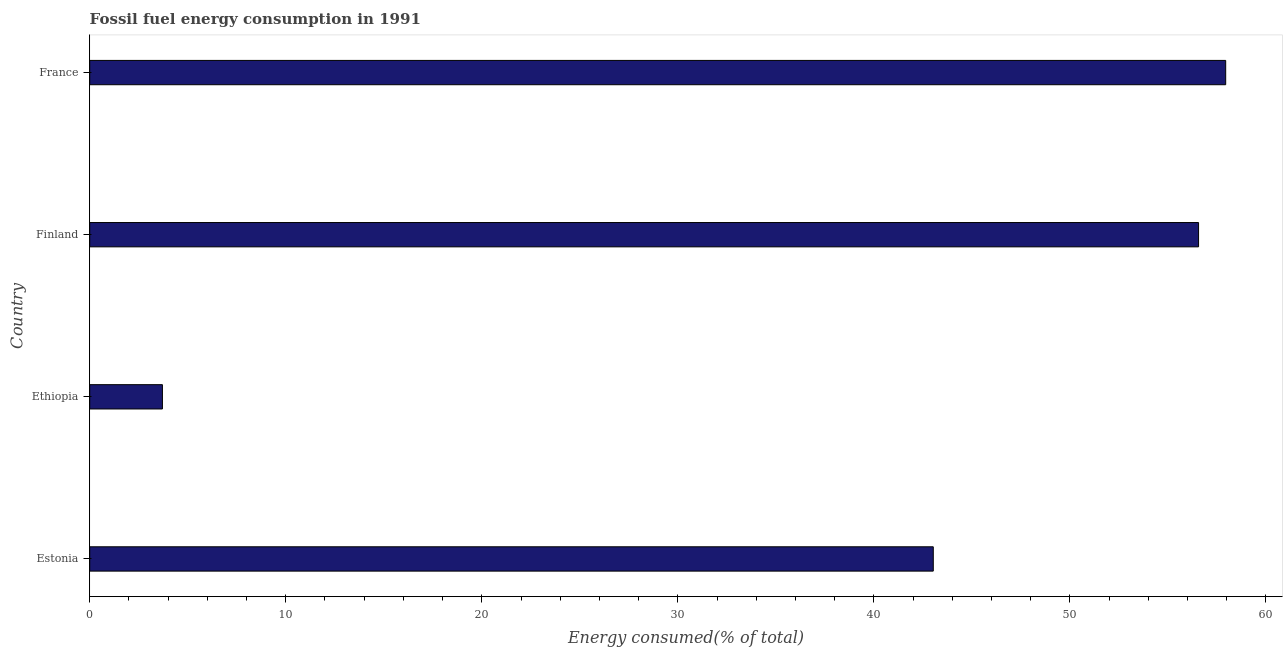What is the title of the graph?
Your answer should be compact. Fossil fuel energy consumption in 1991. What is the label or title of the X-axis?
Give a very brief answer. Energy consumed(% of total). What is the fossil fuel energy consumption in Ethiopia?
Offer a very short reply. 3.71. Across all countries, what is the maximum fossil fuel energy consumption?
Offer a very short reply. 57.95. Across all countries, what is the minimum fossil fuel energy consumption?
Your answer should be very brief. 3.71. In which country was the fossil fuel energy consumption minimum?
Your response must be concise. Ethiopia. What is the sum of the fossil fuel energy consumption?
Your response must be concise. 161.25. What is the difference between the fossil fuel energy consumption in Ethiopia and France?
Provide a short and direct response. -54.24. What is the average fossil fuel energy consumption per country?
Give a very brief answer. 40.31. What is the median fossil fuel energy consumption?
Make the answer very short. 49.8. In how many countries, is the fossil fuel energy consumption greater than 46 %?
Offer a terse response. 2. What is the ratio of the fossil fuel energy consumption in Estonia to that in Ethiopia?
Your response must be concise. 11.6. Is the fossil fuel energy consumption in Estonia less than that in Finland?
Make the answer very short. Yes. What is the difference between the highest and the second highest fossil fuel energy consumption?
Offer a very short reply. 1.38. What is the difference between the highest and the lowest fossil fuel energy consumption?
Offer a terse response. 54.24. How many countries are there in the graph?
Your answer should be very brief. 4. What is the Energy consumed(% of total) of Estonia?
Offer a terse response. 43.03. What is the Energy consumed(% of total) in Ethiopia?
Give a very brief answer. 3.71. What is the Energy consumed(% of total) in Finland?
Your answer should be compact. 56.56. What is the Energy consumed(% of total) of France?
Provide a succinct answer. 57.95. What is the difference between the Energy consumed(% of total) in Estonia and Ethiopia?
Provide a succinct answer. 39.32. What is the difference between the Energy consumed(% of total) in Estonia and Finland?
Provide a succinct answer. -13.53. What is the difference between the Energy consumed(% of total) in Estonia and France?
Your answer should be compact. -14.92. What is the difference between the Energy consumed(% of total) in Ethiopia and Finland?
Ensure brevity in your answer.  -52.85. What is the difference between the Energy consumed(% of total) in Ethiopia and France?
Your response must be concise. -54.24. What is the difference between the Energy consumed(% of total) in Finland and France?
Offer a very short reply. -1.38. What is the ratio of the Energy consumed(% of total) in Estonia to that in Ethiopia?
Make the answer very short. 11.6. What is the ratio of the Energy consumed(% of total) in Estonia to that in Finland?
Ensure brevity in your answer.  0.76. What is the ratio of the Energy consumed(% of total) in Estonia to that in France?
Ensure brevity in your answer.  0.74. What is the ratio of the Energy consumed(% of total) in Ethiopia to that in Finland?
Offer a terse response. 0.07. What is the ratio of the Energy consumed(% of total) in Ethiopia to that in France?
Provide a short and direct response. 0.06. What is the ratio of the Energy consumed(% of total) in Finland to that in France?
Your response must be concise. 0.98. 